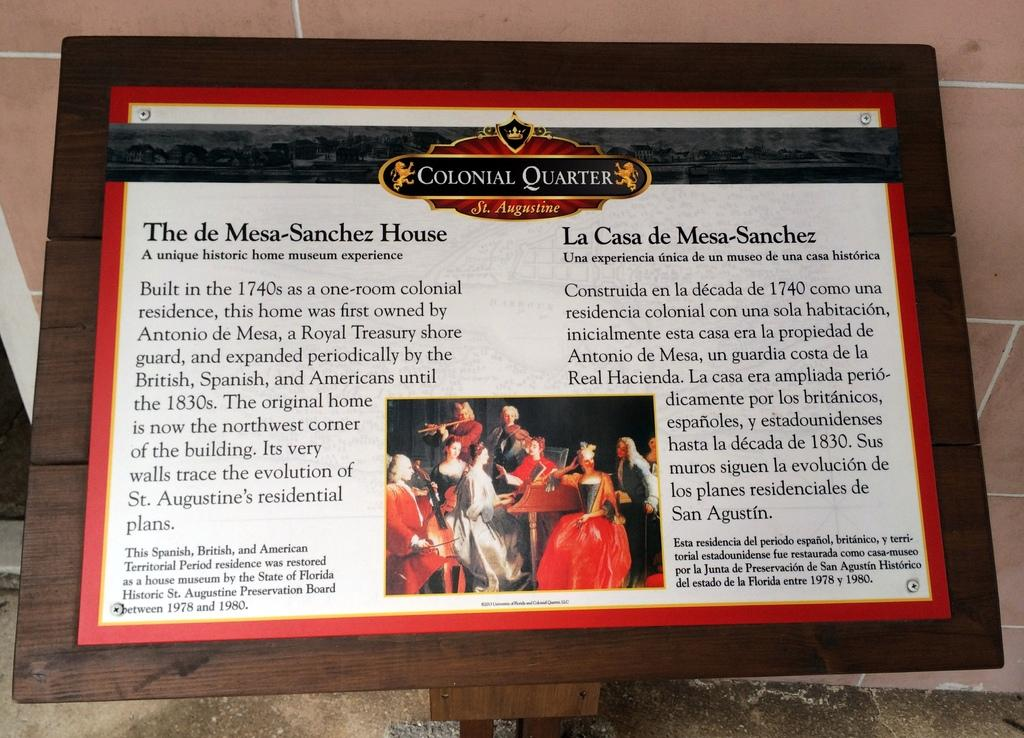<image>
Write a terse but informative summary of the picture. a paper item that says colonial quarter on it 